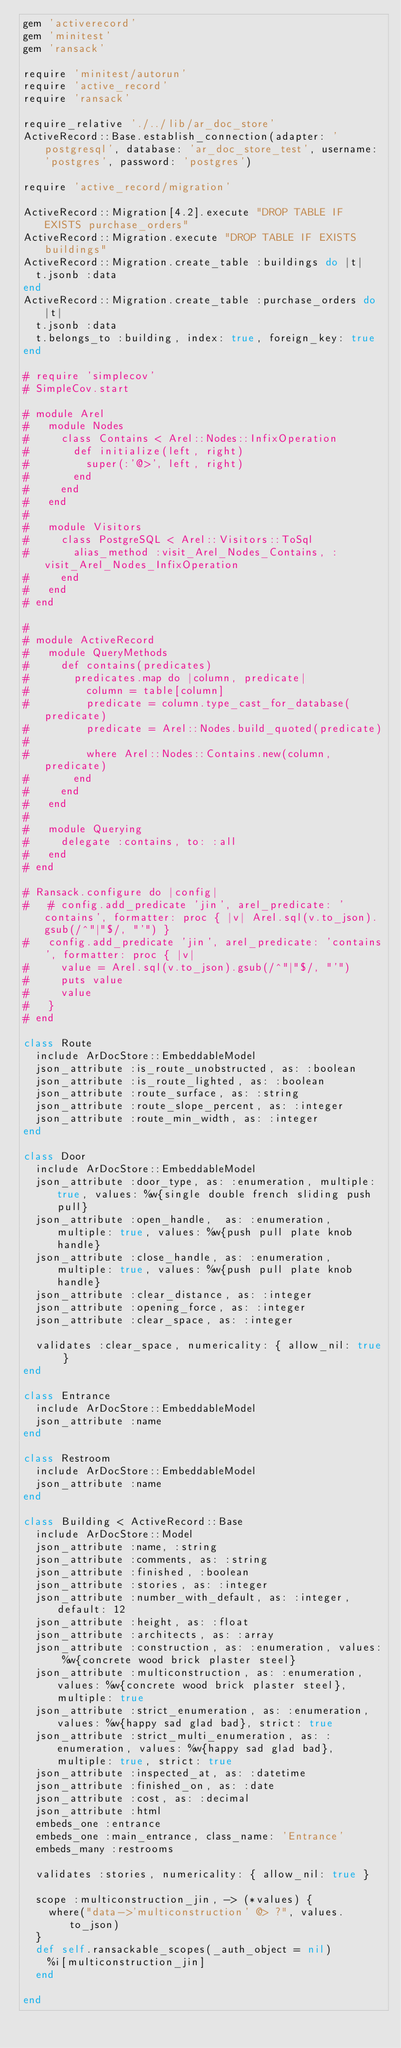Convert code to text. <code><loc_0><loc_0><loc_500><loc_500><_Ruby_>gem 'activerecord'
gem 'minitest'
gem 'ransack'

require 'minitest/autorun'
require 'active_record'
require 'ransack'

require_relative './../lib/ar_doc_store'
ActiveRecord::Base.establish_connection(adapter: 'postgresql', database: 'ar_doc_store_test', username: 'postgres', password: 'postgres')

require 'active_record/migration'

ActiveRecord::Migration[4.2].execute "DROP TABLE IF EXISTS purchase_orders"
ActiveRecord::Migration.execute "DROP TABLE IF EXISTS buildings"
ActiveRecord::Migration.create_table :buildings do |t|
  t.jsonb :data
end
ActiveRecord::Migration.create_table :purchase_orders do |t|
  t.jsonb :data
  t.belongs_to :building, index: true, foreign_key: true
end

# require 'simplecov'
# SimpleCov.start

# module Arel
#   module Nodes
#     class Contains < Arel::Nodes::InfixOperation
#       def initialize(left, right)
#         super(:'@>', left, right)
#       end
#     end
#   end
#
#   module Visitors
#     class PostgreSQL < Arel::Visitors::ToSql
#       alias_method :visit_Arel_Nodes_Contains, :visit_Arel_Nodes_InfixOperation
#     end
#   end
# end

#
# module ActiveRecord
#   module QueryMethods
#     def contains(predicates)
#       predicates.map do |column, predicate|
#         column = table[column]
#         predicate = column.type_cast_for_database(predicate)
#         predicate = Arel::Nodes.build_quoted(predicate)
#
#         where Arel::Nodes::Contains.new(column, predicate)
#       end
#     end
#   end
#
#   module Querying
#     delegate :contains, to: :all
#   end
# end

# Ransack.configure do |config|
#   # config.add_predicate 'jin', arel_predicate: 'contains', formatter: proc { |v| Arel.sql(v.to_json).gsub(/^"|"$/, "'") }
#   config.add_predicate 'jin', arel_predicate: 'contains', formatter: proc { |v|
#     value = Arel.sql(v.to_json).gsub(/^"|"$/, "'")
#     puts value
#     value
#   }
# end

class Route
  include ArDocStore::EmbeddableModel
  json_attribute :is_route_unobstructed, as: :boolean
  json_attribute :is_route_lighted, as: :boolean
  json_attribute :route_surface, as: :string
  json_attribute :route_slope_percent, as: :integer
  json_attribute :route_min_width, as: :integer
end

class Door
  include ArDocStore::EmbeddableModel
  json_attribute :door_type, as: :enumeration, multiple: true, values: %w{single double french sliding push pull}
  json_attribute :open_handle,  as: :enumeration, multiple: true, values: %w{push pull plate knob handle}
  json_attribute :close_handle, as: :enumeration, multiple: true, values: %w{push pull plate knob handle}
  json_attribute :clear_distance, as: :integer
  json_attribute :opening_force, as: :integer
  json_attribute :clear_space, as: :integer

  validates :clear_space, numericality: { allow_nil: true }
end

class Entrance
  include ArDocStore::EmbeddableModel
  json_attribute :name
end

class Restroom
  include ArDocStore::EmbeddableModel
  json_attribute :name
end

class Building < ActiveRecord::Base
  include ArDocStore::Model
  json_attribute :name, :string
  json_attribute :comments, as: :string
  json_attribute :finished, :boolean
  json_attribute :stories, as: :integer
  json_attribute :number_with_default, as: :integer, default: 12
  json_attribute :height, as: :float
  json_attribute :architects, as: :array
  json_attribute :construction, as: :enumeration, values: %w{concrete wood brick plaster steel}
  json_attribute :multiconstruction, as: :enumeration, values: %w{concrete wood brick plaster steel}, multiple: true
  json_attribute :strict_enumeration, as: :enumeration, values: %w{happy sad glad bad}, strict: true
  json_attribute :strict_multi_enumeration, as: :enumeration, values: %w{happy sad glad bad}, multiple: true, strict: true
  json_attribute :inspected_at, as: :datetime
  json_attribute :finished_on, as: :date
  json_attribute :cost, as: :decimal
  json_attribute :html
  embeds_one :entrance
  embeds_one :main_entrance, class_name: 'Entrance'
  embeds_many :restrooms

  validates :stories, numericality: { allow_nil: true }

  scope :multiconstruction_jin, -> (*values) {
    where("data->'multiconstruction' @> ?", values.to_json)
  }
  def self.ransackable_scopes(_auth_object = nil)
    %i[multiconstruction_jin]
  end

end

</code> 